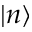<formula> <loc_0><loc_0><loc_500><loc_500>| n \rangle</formula> 